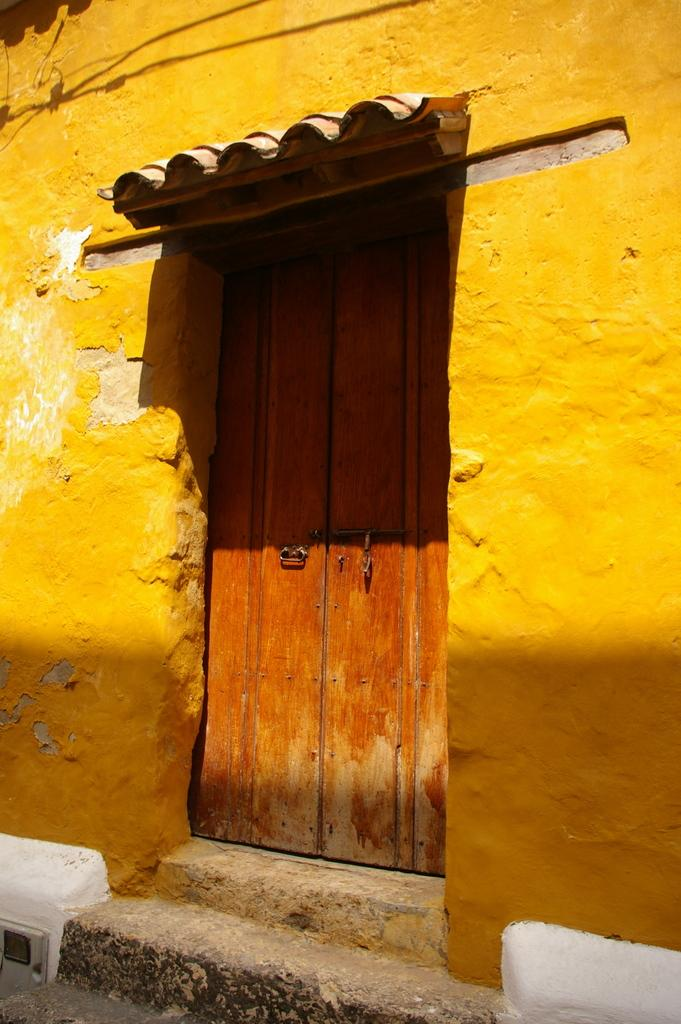What color is the wall in the image? The wall in the image is yellow. What color is the door in the image? The door in the image is brown. What architectural feature is present at the bottom of the image? Stairs are present at the bottom of the image. What type of scent can be detected in the image? There is no information about a scent in the image, so it cannot be determined. 